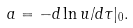<formula> <loc_0><loc_0><loc_500><loc_500>a = - d \ln u / d \tau | _ { 0 } .</formula> 